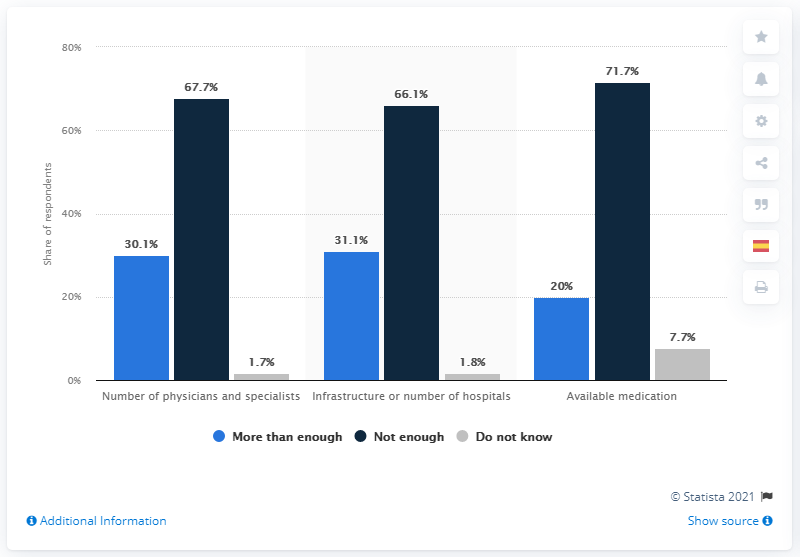Specify some key components in this picture. According to the respondents, 67.7% of them believed that there were not enough number of physicians and specialists available. Seven point seven percent of respondents answered "Do not know" when asked about available medication. According to the survey results, 30.1% of respondents believed that the number of doctors and specialists in Mexico was sufficient to handle the COVID-19 pandemic. 